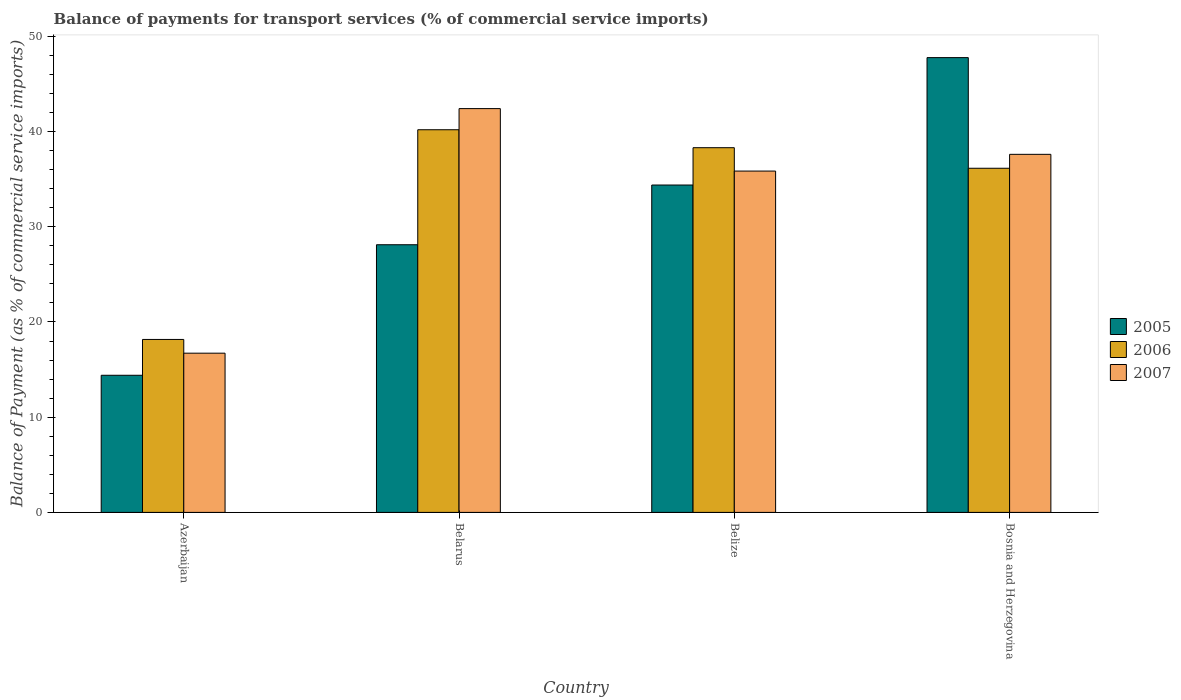Are the number of bars per tick equal to the number of legend labels?
Keep it short and to the point. Yes. Are the number of bars on each tick of the X-axis equal?
Provide a succinct answer. Yes. What is the label of the 4th group of bars from the left?
Ensure brevity in your answer.  Bosnia and Herzegovina. In how many cases, is the number of bars for a given country not equal to the number of legend labels?
Your response must be concise. 0. What is the balance of payments for transport services in 2005 in Bosnia and Herzegovina?
Give a very brief answer. 47.76. Across all countries, what is the maximum balance of payments for transport services in 2006?
Ensure brevity in your answer.  40.19. Across all countries, what is the minimum balance of payments for transport services in 2005?
Provide a succinct answer. 14.4. In which country was the balance of payments for transport services in 2007 maximum?
Ensure brevity in your answer.  Belarus. In which country was the balance of payments for transport services in 2005 minimum?
Keep it short and to the point. Azerbaijan. What is the total balance of payments for transport services in 2006 in the graph?
Your answer should be very brief. 132.8. What is the difference between the balance of payments for transport services in 2007 in Azerbaijan and that in Belarus?
Your answer should be compact. -25.69. What is the difference between the balance of payments for transport services in 2005 in Bosnia and Herzegovina and the balance of payments for transport services in 2007 in Belarus?
Give a very brief answer. 5.36. What is the average balance of payments for transport services in 2005 per country?
Give a very brief answer. 31.16. What is the difference between the balance of payments for transport services of/in 2006 and balance of payments for transport services of/in 2007 in Bosnia and Herzegovina?
Keep it short and to the point. -1.46. What is the ratio of the balance of payments for transport services in 2006 in Azerbaijan to that in Belarus?
Offer a terse response. 0.45. Is the balance of payments for transport services in 2005 in Azerbaijan less than that in Bosnia and Herzegovina?
Your answer should be compact. Yes. What is the difference between the highest and the second highest balance of payments for transport services in 2006?
Offer a very short reply. 4.04. What is the difference between the highest and the lowest balance of payments for transport services in 2007?
Your response must be concise. 25.69. In how many countries, is the balance of payments for transport services in 2007 greater than the average balance of payments for transport services in 2007 taken over all countries?
Provide a short and direct response. 3. Is the sum of the balance of payments for transport services in 2007 in Belize and Bosnia and Herzegovina greater than the maximum balance of payments for transport services in 2006 across all countries?
Provide a succinct answer. Yes. What does the 2nd bar from the left in Azerbaijan represents?
Keep it short and to the point. 2006. Is it the case that in every country, the sum of the balance of payments for transport services in 2007 and balance of payments for transport services in 2006 is greater than the balance of payments for transport services in 2005?
Provide a short and direct response. Yes. Does the graph contain any zero values?
Your answer should be compact. No. How many legend labels are there?
Provide a succinct answer. 3. How are the legend labels stacked?
Keep it short and to the point. Vertical. What is the title of the graph?
Give a very brief answer. Balance of payments for transport services (% of commercial service imports). What is the label or title of the X-axis?
Make the answer very short. Country. What is the label or title of the Y-axis?
Offer a terse response. Balance of Payment (as % of commercial service imports). What is the Balance of Payment (as % of commercial service imports) in 2005 in Azerbaijan?
Provide a short and direct response. 14.4. What is the Balance of Payment (as % of commercial service imports) in 2006 in Azerbaijan?
Ensure brevity in your answer.  18.16. What is the Balance of Payment (as % of commercial service imports) of 2007 in Azerbaijan?
Your response must be concise. 16.72. What is the Balance of Payment (as % of commercial service imports) of 2005 in Belarus?
Your answer should be very brief. 28.11. What is the Balance of Payment (as % of commercial service imports) of 2006 in Belarus?
Make the answer very short. 40.19. What is the Balance of Payment (as % of commercial service imports) in 2007 in Belarus?
Your answer should be very brief. 42.41. What is the Balance of Payment (as % of commercial service imports) in 2005 in Belize?
Your response must be concise. 34.38. What is the Balance of Payment (as % of commercial service imports) of 2006 in Belize?
Your response must be concise. 38.3. What is the Balance of Payment (as % of commercial service imports) in 2007 in Belize?
Offer a very short reply. 35.85. What is the Balance of Payment (as % of commercial service imports) in 2005 in Bosnia and Herzegovina?
Your response must be concise. 47.76. What is the Balance of Payment (as % of commercial service imports) of 2006 in Bosnia and Herzegovina?
Offer a very short reply. 36.14. What is the Balance of Payment (as % of commercial service imports) of 2007 in Bosnia and Herzegovina?
Offer a very short reply. 37.6. Across all countries, what is the maximum Balance of Payment (as % of commercial service imports) in 2005?
Make the answer very short. 47.76. Across all countries, what is the maximum Balance of Payment (as % of commercial service imports) of 2006?
Your response must be concise. 40.19. Across all countries, what is the maximum Balance of Payment (as % of commercial service imports) of 2007?
Your answer should be very brief. 42.41. Across all countries, what is the minimum Balance of Payment (as % of commercial service imports) in 2005?
Keep it short and to the point. 14.4. Across all countries, what is the minimum Balance of Payment (as % of commercial service imports) of 2006?
Your response must be concise. 18.16. Across all countries, what is the minimum Balance of Payment (as % of commercial service imports) in 2007?
Offer a very short reply. 16.72. What is the total Balance of Payment (as % of commercial service imports) in 2005 in the graph?
Your response must be concise. 124.66. What is the total Balance of Payment (as % of commercial service imports) in 2006 in the graph?
Provide a short and direct response. 132.8. What is the total Balance of Payment (as % of commercial service imports) of 2007 in the graph?
Ensure brevity in your answer.  132.58. What is the difference between the Balance of Payment (as % of commercial service imports) of 2005 in Azerbaijan and that in Belarus?
Provide a short and direct response. -13.71. What is the difference between the Balance of Payment (as % of commercial service imports) of 2006 in Azerbaijan and that in Belarus?
Give a very brief answer. -22.02. What is the difference between the Balance of Payment (as % of commercial service imports) of 2007 in Azerbaijan and that in Belarus?
Offer a very short reply. -25.69. What is the difference between the Balance of Payment (as % of commercial service imports) of 2005 in Azerbaijan and that in Belize?
Keep it short and to the point. -19.98. What is the difference between the Balance of Payment (as % of commercial service imports) in 2006 in Azerbaijan and that in Belize?
Provide a succinct answer. -20.14. What is the difference between the Balance of Payment (as % of commercial service imports) in 2007 in Azerbaijan and that in Belize?
Keep it short and to the point. -19.13. What is the difference between the Balance of Payment (as % of commercial service imports) of 2005 in Azerbaijan and that in Bosnia and Herzegovina?
Your response must be concise. -33.36. What is the difference between the Balance of Payment (as % of commercial service imports) in 2006 in Azerbaijan and that in Bosnia and Herzegovina?
Offer a terse response. -17.98. What is the difference between the Balance of Payment (as % of commercial service imports) in 2007 in Azerbaijan and that in Bosnia and Herzegovina?
Offer a very short reply. -20.88. What is the difference between the Balance of Payment (as % of commercial service imports) of 2005 in Belarus and that in Belize?
Your response must be concise. -6.27. What is the difference between the Balance of Payment (as % of commercial service imports) of 2006 in Belarus and that in Belize?
Provide a succinct answer. 1.89. What is the difference between the Balance of Payment (as % of commercial service imports) in 2007 in Belarus and that in Belize?
Your answer should be very brief. 6.56. What is the difference between the Balance of Payment (as % of commercial service imports) of 2005 in Belarus and that in Bosnia and Herzegovina?
Provide a succinct answer. -19.65. What is the difference between the Balance of Payment (as % of commercial service imports) of 2006 in Belarus and that in Bosnia and Herzegovina?
Make the answer very short. 4.04. What is the difference between the Balance of Payment (as % of commercial service imports) in 2007 in Belarus and that in Bosnia and Herzegovina?
Ensure brevity in your answer.  4.8. What is the difference between the Balance of Payment (as % of commercial service imports) of 2005 in Belize and that in Bosnia and Herzegovina?
Give a very brief answer. -13.38. What is the difference between the Balance of Payment (as % of commercial service imports) of 2006 in Belize and that in Bosnia and Herzegovina?
Provide a short and direct response. 2.16. What is the difference between the Balance of Payment (as % of commercial service imports) of 2007 in Belize and that in Bosnia and Herzegovina?
Your response must be concise. -1.76. What is the difference between the Balance of Payment (as % of commercial service imports) of 2005 in Azerbaijan and the Balance of Payment (as % of commercial service imports) of 2006 in Belarus?
Your response must be concise. -25.79. What is the difference between the Balance of Payment (as % of commercial service imports) of 2005 in Azerbaijan and the Balance of Payment (as % of commercial service imports) of 2007 in Belarus?
Offer a very short reply. -28.01. What is the difference between the Balance of Payment (as % of commercial service imports) of 2006 in Azerbaijan and the Balance of Payment (as % of commercial service imports) of 2007 in Belarus?
Ensure brevity in your answer.  -24.24. What is the difference between the Balance of Payment (as % of commercial service imports) in 2005 in Azerbaijan and the Balance of Payment (as % of commercial service imports) in 2006 in Belize?
Provide a succinct answer. -23.9. What is the difference between the Balance of Payment (as % of commercial service imports) in 2005 in Azerbaijan and the Balance of Payment (as % of commercial service imports) in 2007 in Belize?
Your answer should be very brief. -21.45. What is the difference between the Balance of Payment (as % of commercial service imports) of 2006 in Azerbaijan and the Balance of Payment (as % of commercial service imports) of 2007 in Belize?
Offer a very short reply. -17.68. What is the difference between the Balance of Payment (as % of commercial service imports) in 2005 in Azerbaijan and the Balance of Payment (as % of commercial service imports) in 2006 in Bosnia and Herzegovina?
Keep it short and to the point. -21.74. What is the difference between the Balance of Payment (as % of commercial service imports) in 2005 in Azerbaijan and the Balance of Payment (as % of commercial service imports) in 2007 in Bosnia and Herzegovina?
Give a very brief answer. -23.2. What is the difference between the Balance of Payment (as % of commercial service imports) of 2006 in Azerbaijan and the Balance of Payment (as % of commercial service imports) of 2007 in Bosnia and Herzegovina?
Your response must be concise. -19.44. What is the difference between the Balance of Payment (as % of commercial service imports) in 2005 in Belarus and the Balance of Payment (as % of commercial service imports) in 2006 in Belize?
Provide a succinct answer. -10.19. What is the difference between the Balance of Payment (as % of commercial service imports) of 2005 in Belarus and the Balance of Payment (as % of commercial service imports) of 2007 in Belize?
Ensure brevity in your answer.  -7.74. What is the difference between the Balance of Payment (as % of commercial service imports) in 2006 in Belarus and the Balance of Payment (as % of commercial service imports) in 2007 in Belize?
Your answer should be very brief. 4.34. What is the difference between the Balance of Payment (as % of commercial service imports) in 2005 in Belarus and the Balance of Payment (as % of commercial service imports) in 2006 in Bosnia and Herzegovina?
Your answer should be very brief. -8.03. What is the difference between the Balance of Payment (as % of commercial service imports) of 2005 in Belarus and the Balance of Payment (as % of commercial service imports) of 2007 in Bosnia and Herzegovina?
Ensure brevity in your answer.  -9.49. What is the difference between the Balance of Payment (as % of commercial service imports) of 2006 in Belarus and the Balance of Payment (as % of commercial service imports) of 2007 in Bosnia and Herzegovina?
Give a very brief answer. 2.58. What is the difference between the Balance of Payment (as % of commercial service imports) in 2005 in Belize and the Balance of Payment (as % of commercial service imports) in 2006 in Bosnia and Herzegovina?
Make the answer very short. -1.76. What is the difference between the Balance of Payment (as % of commercial service imports) of 2005 in Belize and the Balance of Payment (as % of commercial service imports) of 2007 in Bosnia and Herzegovina?
Make the answer very short. -3.22. What is the difference between the Balance of Payment (as % of commercial service imports) of 2006 in Belize and the Balance of Payment (as % of commercial service imports) of 2007 in Bosnia and Herzegovina?
Provide a short and direct response. 0.7. What is the average Balance of Payment (as % of commercial service imports) of 2005 per country?
Give a very brief answer. 31.16. What is the average Balance of Payment (as % of commercial service imports) in 2006 per country?
Your answer should be compact. 33.2. What is the average Balance of Payment (as % of commercial service imports) in 2007 per country?
Provide a short and direct response. 33.15. What is the difference between the Balance of Payment (as % of commercial service imports) of 2005 and Balance of Payment (as % of commercial service imports) of 2006 in Azerbaijan?
Ensure brevity in your answer.  -3.76. What is the difference between the Balance of Payment (as % of commercial service imports) in 2005 and Balance of Payment (as % of commercial service imports) in 2007 in Azerbaijan?
Ensure brevity in your answer.  -2.32. What is the difference between the Balance of Payment (as % of commercial service imports) in 2006 and Balance of Payment (as % of commercial service imports) in 2007 in Azerbaijan?
Offer a terse response. 1.44. What is the difference between the Balance of Payment (as % of commercial service imports) in 2005 and Balance of Payment (as % of commercial service imports) in 2006 in Belarus?
Your answer should be compact. -12.08. What is the difference between the Balance of Payment (as % of commercial service imports) of 2005 and Balance of Payment (as % of commercial service imports) of 2007 in Belarus?
Offer a very short reply. -14.3. What is the difference between the Balance of Payment (as % of commercial service imports) of 2006 and Balance of Payment (as % of commercial service imports) of 2007 in Belarus?
Your answer should be compact. -2.22. What is the difference between the Balance of Payment (as % of commercial service imports) of 2005 and Balance of Payment (as % of commercial service imports) of 2006 in Belize?
Offer a very short reply. -3.92. What is the difference between the Balance of Payment (as % of commercial service imports) in 2005 and Balance of Payment (as % of commercial service imports) in 2007 in Belize?
Your answer should be very brief. -1.46. What is the difference between the Balance of Payment (as % of commercial service imports) of 2006 and Balance of Payment (as % of commercial service imports) of 2007 in Belize?
Your answer should be compact. 2.46. What is the difference between the Balance of Payment (as % of commercial service imports) in 2005 and Balance of Payment (as % of commercial service imports) in 2006 in Bosnia and Herzegovina?
Your answer should be very brief. 11.62. What is the difference between the Balance of Payment (as % of commercial service imports) of 2005 and Balance of Payment (as % of commercial service imports) of 2007 in Bosnia and Herzegovina?
Make the answer very short. 10.16. What is the difference between the Balance of Payment (as % of commercial service imports) of 2006 and Balance of Payment (as % of commercial service imports) of 2007 in Bosnia and Herzegovina?
Keep it short and to the point. -1.46. What is the ratio of the Balance of Payment (as % of commercial service imports) in 2005 in Azerbaijan to that in Belarus?
Make the answer very short. 0.51. What is the ratio of the Balance of Payment (as % of commercial service imports) in 2006 in Azerbaijan to that in Belarus?
Offer a very short reply. 0.45. What is the ratio of the Balance of Payment (as % of commercial service imports) of 2007 in Azerbaijan to that in Belarus?
Provide a succinct answer. 0.39. What is the ratio of the Balance of Payment (as % of commercial service imports) in 2005 in Azerbaijan to that in Belize?
Make the answer very short. 0.42. What is the ratio of the Balance of Payment (as % of commercial service imports) in 2006 in Azerbaijan to that in Belize?
Give a very brief answer. 0.47. What is the ratio of the Balance of Payment (as % of commercial service imports) of 2007 in Azerbaijan to that in Belize?
Keep it short and to the point. 0.47. What is the ratio of the Balance of Payment (as % of commercial service imports) in 2005 in Azerbaijan to that in Bosnia and Herzegovina?
Your answer should be compact. 0.3. What is the ratio of the Balance of Payment (as % of commercial service imports) in 2006 in Azerbaijan to that in Bosnia and Herzegovina?
Offer a terse response. 0.5. What is the ratio of the Balance of Payment (as % of commercial service imports) in 2007 in Azerbaijan to that in Bosnia and Herzegovina?
Your answer should be compact. 0.44. What is the ratio of the Balance of Payment (as % of commercial service imports) in 2005 in Belarus to that in Belize?
Ensure brevity in your answer.  0.82. What is the ratio of the Balance of Payment (as % of commercial service imports) of 2006 in Belarus to that in Belize?
Provide a succinct answer. 1.05. What is the ratio of the Balance of Payment (as % of commercial service imports) of 2007 in Belarus to that in Belize?
Give a very brief answer. 1.18. What is the ratio of the Balance of Payment (as % of commercial service imports) in 2005 in Belarus to that in Bosnia and Herzegovina?
Offer a terse response. 0.59. What is the ratio of the Balance of Payment (as % of commercial service imports) of 2006 in Belarus to that in Bosnia and Herzegovina?
Your answer should be compact. 1.11. What is the ratio of the Balance of Payment (as % of commercial service imports) of 2007 in Belarus to that in Bosnia and Herzegovina?
Make the answer very short. 1.13. What is the ratio of the Balance of Payment (as % of commercial service imports) of 2005 in Belize to that in Bosnia and Herzegovina?
Keep it short and to the point. 0.72. What is the ratio of the Balance of Payment (as % of commercial service imports) in 2006 in Belize to that in Bosnia and Herzegovina?
Give a very brief answer. 1.06. What is the ratio of the Balance of Payment (as % of commercial service imports) in 2007 in Belize to that in Bosnia and Herzegovina?
Provide a short and direct response. 0.95. What is the difference between the highest and the second highest Balance of Payment (as % of commercial service imports) in 2005?
Your response must be concise. 13.38. What is the difference between the highest and the second highest Balance of Payment (as % of commercial service imports) in 2006?
Your response must be concise. 1.89. What is the difference between the highest and the second highest Balance of Payment (as % of commercial service imports) of 2007?
Ensure brevity in your answer.  4.8. What is the difference between the highest and the lowest Balance of Payment (as % of commercial service imports) of 2005?
Give a very brief answer. 33.36. What is the difference between the highest and the lowest Balance of Payment (as % of commercial service imports) of 2006?
Provide a succinct answer. 22.02. What is the difference between the highest and the lowest Balance of Payment (as % of commercial service imports) in 2007?
Make the answer very short. 25.69. 